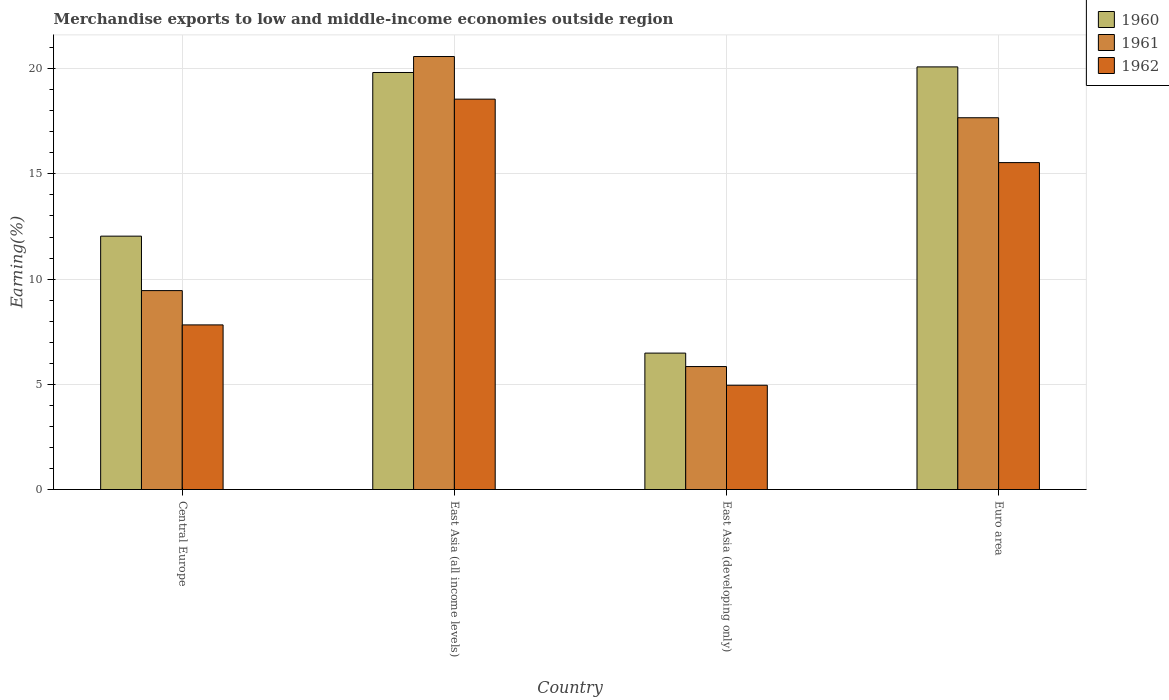How many groups of bars are there?
Ensure brevity in your answer.  4. What is the label of the 1st group of bars from the left?
Your answer should be compact. Central Europe. In how many cases, is the number of bars for a given country not equal to the number of legend labels?
Offer a very short reply. 0. What is the percentage of amount earned from merchandise exports in 1961 in Euro area?
Your answer should be compact. 17.67. Across all countries, what is the maximum percentage of amount earned from merchandise exports in 1962?
Provide a succinct answer. 18.55. Across all countries, what is the minimum percentage of amount earned from merchandise exports in 1961?
Your answer should be very brief. 5.84. In which country was the percentage of amount earned from merchandise exports in 1961 maximum?
Keep it short and to the point. East Asia (all income levels). In which country was the percentage of amount earned from merchandise exports in 1962 minimum?
Offer a terse response. East Asia (developing only). What is the total percentage of amount earned from merchandise exports in 1960 in the graph?
Keep it short and to the point. 58.43. What is the difference between the percentage of amount earned from merchandise exports in 1962 in Central Europe and that in East Asia (all income levels)?
Offer a terse response. -10.73. What is the difference between the percentage of amount earned from merchandise exports in 1961 in Central Europe and the percentage of amount earned from merchandise exports in 1962 in East Asia (developing only)?
Give a very brief answer. 4.5. What is the average percentage of amount earned from merchandise exports in 1960 per country?
Keep it short and to the point. 14.61. What is the difference between the percentage of amount earned from merchandise exports of/in 1962 and percentage of amount earned from merchandise exports of/in 1960 in Euro area?
Offer a very short reply. -4.55. In how many countries, is the percentage of amount earned from merchandise exports in 1962 greater than 18 %?
Your response must be concise. 1. What is the ratio of the percentage of amount earned from merchandise exports in 1961 in Central Europe to that in Euro area?
Make the answer very short. 0.54. Is the difference between the percentage of amount earned from merchandise exports in 1962 in Central Europe and Euro area greater than the difference between the percentage of amount earned from merchandise exports in 1960 in Central Europe and Euro area?
Your response must be concise. Yes. What is the difference between the highest and the second highest percentage of amount earned from merchandise exports in 1961?
Make the answer very short. -2.91. What is the difference between the highest and the lowest percentage of amount earned from merchandise exports in 1961?
Keep it short and to the point. 14.73. In how many countries, is the percentage of amount earned from merchandise exports in 1962 greater than the average percentage of amount earned from merchandise exports in 1962 taken over all countries?
Your answer should be very brief. 2. Is the sum of the percentage of amount earned from merchandise exports in 1962 in East Asia (all income levels) and Euro area greater than the maximum percentage of amount earned from merchandise exports in 1961 across all countries?
Offer a terse response. Yes. Is it the case that in every country, the sum of the percentage of amount earned from merchandise exports in 1960 and percentage of amount earned from merchandise exports in 1962 is greater than the percentage of amount earned from merchandise exports in 1961?
Offer a terse response. Yes. How many bars are there?
Your answer should be very brief. 12. Are all the bars in the graph horizontal?
Give a very brief answer. No. How many countries are there in the graph?
Your answer should be compact. 4. What is the difference between two consecutive major ticks on the Y-axis?
Make the answer very short. 5. Are the values on the major ticks of Y-axis written in scientific E-notation?
Offer a terse response. No. Does the graph contain any zero values?
Your response must be concise. No. Does the graph contain grids?
Your response must be concise. Yes. What is the title of the graph?
Your answer should be very brief. Merchandise exports to low and middle-income economies outside region. Does "1970" appear as one of the legend labels in the graph?
Provide a short and direct response. No. What is the label or title of the Y-axis?
Provide a short and direct response. Earning(%). What is the Earning(%) in 1960 in Central Europe?
Offer a terse response. 12.04. What is the Earning(%) in 1961 in Central Europe?
Make the answer very short. 9.45. What is the Earning(%) in 1962 in Central Europe?
Your answer should be very brief. 7.82. What is the Earning(%) of 1960 in East Asia (all income levels)?
Give a very brief answer. 19.82. What is the Earning(%) in 1961 in East Asia (all income levels)?
Your response must be concise. 20.58. What is the Earning(%) of 1962 in East Asia (all income levels)?
Your answer should be very brief. 18.55. What is the Earning(%) of 1960 in East Asia (developing only)?
Give a very brief answer. 6.48. What is the Earning(%) in 1961 in East Asia (developing only)?
Ensure brevity in your answer.  5.84. What is the Earning(%) of 1962 in East Asia (developing only)?
Make the answer very short. 4.96. What is the Earning(%) in 1960 in Euro area?
Give a very brief answer. 20.08. What is the Earning(%) of 1961 in Euro area?
Provide a succinct answer. 17.67. What is the Earning(%) in 1962 in Euro area?
Give a very brief answer. 15.54. Across all countries, what is the maximum Earning(%) of 1960?
Your answer should be compact. 20.08. Across all countries, what is the maximum Earning(%) of 1961?
Offer a terse response. 20.58. Across all countries, what is the maximum Earning(%) in 1962?
Offer a terse response. 18.55. Across all countries, what is the minimum Earning(%) of 1960?
Your answer should be very brief. 6.48. Across all countries, what is the minimum Earning(%) in 1961?
Your response must be concise. 5.84. Across all countries, what is the minimum Earning(%) in 1962?
Keep it short and to the point. 4.96. What is the total Earning(%) in 1960 in the graph?
Your answer should be compact. 58.43. What is the total Earning(%) of 1961 in the graph?
Provide a short and direct response. 53.54. What is the total Earning(%) of 1962 in the graph?
Offer a terse response. 46.87. What is the difference between the Earning(%) of 1960 in Central Europe and that in East Asia (all income levels)?
Give a very brief answer. -7.78. What is the difference between the Earning(%) of 1961 in Central Europe and that in East Asia (all income levels)?
Offer a very short reply. -11.12. What is the difference between the Earning(%) in 1962 in Central Europe and that in East Asia (all income levels)?
Ensure brevity in your answer.  -10.73. What is the difference between the Earning(%) of 1960 in Central Europe and that in East Asia (developing only)?
Keep it short and to the point. 5.56. What is the difference between the Earning(%) in 1961 in Central Europe and that in East Asia (developing only)?
Keep it short and to the point. 3.61. What is the difference between the Earning(%) of 1962 in Central Europe and that in East Asia (developing only)?
Provide a succinct answer. 2.87. What is the difference between the Earning(%) of 1960 in Central Europe and that in Euro area?
Offer a very short reply. -8.04. What is the difference between the Earning(%) of 1961 in Central Europe and that in Euro area?
Your answer should be very brief. -8.21. What is the difference between the Earning(%) in 1962 in Central Europe and that in Euro area?
Provide a succinct answer. -7.71. What is the difference between the Earning(%) of 1960 in East Asia (all income levels) and that in East Asia (developing only)?
Provide a succinct answer. 13.33. What is the difference between the Earning(%) of 1961 in East Asia (all income levels) and that in East Asia (developing only)?
Make the answer very short. 14.73. What is the difference between the Earning(%) of 1962 in East Asia (all income levels) and that in East Asia (developing only)?
Ensure brevity in your answer.  13.6. What is the difference between the Earning(%) in 1960 in East Asia (all income levels) and that in Euro area?
Provide a succinct answer. -0.27. What is the difference between the Earning(%) of 1961 in East Asia (all income levels) and that in Euro area?
Offer a very short reply. 2.91. What is the difference between the Earning(%) of 1962 in East Asia (all income levels) and that in Euro area?
Ensure brevity in your answer.  3.02. What is the difference between the Earning(%) in 1960 in East Asia (developing only) and that in Euro area?
Your answer should be compact. -13.6. What is the difference between the Earning(%) of 1961 in East Asia (developing only) and that in Euro area?
Offer a very short reply. -11.82. What is the difference between the Earning(%) in 1962 in East Asia (developing only) and that in Euro area?
Provide a succinct answer. -10.58. What is the difference between the Earning(%) of 1960 in Central Europe and the Earning(%) of 1961 in East Asia (all income levels)?
Your answer should be compact. -8.54. What is the difference between the Earning(%) of 1960 in Central Europe and the Earning(%) of 1962 in East Asia (all income levels)?
Provide a succinct answer. -6.51. What is the difference between the Earning(%) in 1961 in Central Europe and the Earning(%) in 1962 in East Asia (all income levels)?
Keep it short and to the point. -9.1. What is the difference between the Earning(%) of 1960 in Central Europe and the Earning(%) of 1961 in East Asia (developing only)?
Provide a succinct answer. 6.2. What is the difference between the Earning(%) in 1960 in Central Europe and the Earning(%) in 1962 in East Asia (developing only)?
Keep it short and to the point. 7.09. What is the difference between the Earning(%) of 1961 in Central Europe and the Earning(%) of 1962 in East Asia (developing only)?
Your answer should be very brief. 4.5. What is the difference between the Earning(%) in 1960 in Central Europe and the Earning(%) in 1961 in Euro area?
Your answer should be compact. -5.63. What is the difference between the Earning(%) in 1960 in Central Europe and the Earning(%) in 1962 in Euro area?
Make the answer very short. -3.49. What is the difference between the Earning(%) of 1961 in Central Europe and the Earning(%) of 1962 in Euro area?
Your response must be concise. -6.08. What is the difference between the Earning(%) in 1960 in East Asia (all income levels) and the Earning(%) in 1961 in East Asia (developing only)?
Provide a succinct answer. 13.97. What is the difference between the Earning(%) in 1960 in East Asia (all income levels) and the Earning(%) in 1962 in East Asia (developing only)?
Your answer should be very brief. 14.86. What is the difference between the Earning(%) in 1961 in East Asia (all income levels) and the Earning(%) in 1962 in East Asia (developing only)?
Your response must be concise. 15.62. What is the difference between the Earning(%) of 1960 in East Asia (all income levels) and the Earning(%) of 1961 in Euro area?
Give a very brief answer. 2.15. What is the difference between the Earning(%) in 1960 in East Asia (all income levels) and the Earning(%) in 1962 in Euro area?
Provide a short and direct response. 4.28. What is the difference between the Earning(%) of 1961 in East Asia (all income levels) and the Earning(%) of 1962 in Euro area?
Your answer should be compact. 5.04. What is the difference between the Earning(%) in 1960 in East Asia (developing only) and the Earning(%) in 1961 in Euro area?
Give a very brief answer. -11.18. What is the difference between the Earning(%) of 1960 in East Asia (developing only) and the Earning(%) of 1962 in Euro area?
Your answer should be very brief. -9.05. What is the difference between the Earning(%) of 1961 in East Asia (developing only) and the Earning(%) of 1962 in Euro area?
Your answer should be compact. -9.69. What is the average Earning(%) in 1960 per country?
Ensure brevity in your answer.  14.61. What is the average Earning(%) in 1961 per country?
Provide a short and direct response. 13.39. What is the average Earning(%) of 1962 per country?
Your answer should be very brief. 11.72. What is the difference between the Earning(%) in 1960 and Earning(%) in 1961 in Central Europe?
Your answer should be very brief. 2.59. What is the difference between the Earning(%) of 1960 and Earning(%) of 1962 in Central Europe?
Offer a very short reply. 4.22. What is the difference between the Earning(%) of 1961 and Earning(%) of 1962 in Central Europe?
Your answer should be very brief. 1.63. What is the difference between the Earning(%) of 1960 and Earning(%) of 1961 in East Asia (all income levels)?
Offer a very short reply. -0.76. What is the difference between the Earning(%) in 1960 and Earning(%) in 1962 in East Asia (all income levels)?
Your response must be concise. 1.27. What is the difference between the Earning(%) of 1961 and Earning(%) of 1962 in East Asia (all income levels)?
Provide a short and direct response. 2.03. What is the difference between the Earning(%) in 1960 and Earning(%) in 1961 in East Asia (developing only)?
Offer a terse response. 0.64. What is the difference between the Earning(%) of 1960 and Earning(%) of 1962 in East Asia (developing only)?
Provide a short and direct response. 1.53. What is the difference between the Earning(%) in 1961 and Earning(%) in 1962 in East Asia (developing only)?
Your response must be concise. 0.89. What is the difference between the Earning(%) in 1960 and Earning(%) in 1961 in Euro area?
Your answer should be very brief. 2.42. What is the difference between the Earning(%) in 1960 and Earning(%) in 1962 in Euro area?
Provide a short and direct response. 4.55. What is the difference between the Earning(%) of 1961 and Earning(%) of 1962 in Euro area?
Make the answer very short. 2.13. What is the ratio of the Earning(%) in 1960 in Central Europe to that in East Asia (all income levels)?
Your answer should be compact. 0.61. What is the ratio of the Earning(%) of 1961 in Central Europe to that in East Asia (all income levels)?
Give a very brief answer. 0.46. What is the ratio of the Earning(%) in 1962 in Central Europe to that in East Asia (all income levels)?
Ensure brevity in your answer.  0.42. What is the ratio of the Earning(%) of 1960 in Central Europe to that in East Asia (developing only)?
Keep it short and to the point. 1.86. What is the ratio of the Earning(%) of 1961 in Central Europe to that in East Asia (developing only)?
Your response must be concise. 1.62. What is the ratio of the Earning(%) in 1962 in Central Europe to that in East Asia (developing only)?
Provide a succinct answer. 1.58. What is the ratio of the Earning(%) of 1960 in Central Europe to that in Euro area?
Your answer should be very brief. 0.6. What is the ratio of the Earning(%) in 1961 in Central Europe to that in Euro area?
Offer a very short reply. 0.54. What is the ratio of the Earning(%) of 1962 in Central Europe to that in Euro area?
Provide a short and direct response. 0.5. What is the ratio of the Earning(%) in 1960 in East Asia (all income levels) to that in East Asia (developing only)?
Provide a succinct answer. 3.06. What is the ratio of the Earning(%) of 1961 in East Asia (all income levels) to that in East Asia (developing only)?
Your answer should be compact. 3.52. What is the ratio of the Earning(%) of 1962 in East Asia (all income levels) to that in East Asia (developing only)?
Your response must be concise. 3.74. What is the ratio of the Earning(%) in 1960 in East Asia (all income levels) to that in Euro area?
Offer a terse response. 0.99. What is the ratio of the Earning(%) in 1961 in East Asia (all income levels) to that in Euro area?
Provide a succinct answer. 1.16. What is the ratio of the Earning(%) of 1962 in East Asia (all income levels) to that in Euro area?
Your response must be concise. 1.19. What is the ratio of the Earning(%) in 1960 in East Asia (developing only) to that in Euro area?
Ensure brevity in your answer.  0.32. What is the ratio of the Earning(%) in 1961 in East Asia (developing only) to that in Euro area?
Provide a short and direct response. 0.33. What is the ratio of the Earning(%) of 1962 in East Asia (developing only) to that in Euro area?
Ensure brevity in your answer.  0.32. What is the difference between the highest and the second highest Earning(%) in 1960?
Your answer should be very brief. 0.27. What is the difference between the highest and the second highest Earning(%) in 1961?
Provide a succinct answer. 2.91. What is the difference between the highest and the second highest Earning(%) of 1962?
Offer a very short reply. 3.02. What is the difference between the highest and the lowest Earning(%) in 1960?
Provide a succinct answer. 13.6. What is the difference between the highest and the lowest Earning(%) of 1961?
Your answer should be compact. 14.73. What is the difference between the highest and the lowest Earning(%) of 1962?
Your response must be concise. 13.6. 